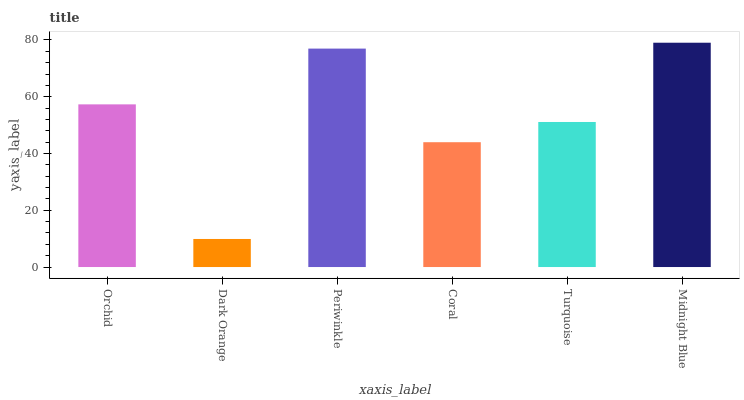Is Dark Orange the minimum?
Answer yes or no. Yes. Is Midnight Blue the maximum?
Answer yes or no. Yes. Is Periwinkle the minimum?
Answer yes or no. No. Is Periwinkle the maximum?
Answer yes or no. No. Is Periwinkle greater than Dark Orange?
Answer yes or no. Yes. Is Dark Orange less than Periwinkle?
Answer yes or no. Yes. Is Dark Orange greater than Periwinkle?
Answer yes or no. No. Is Periwinkle less than Dark Orange?
Answer yes or no. No. Is Orchid the high median?
Answer yes or no. Yes. Is Turquoise the low median?
Answer yes or no. Yes. Is Coral the high median?
Answer yes or no. No. Is Periwinkle the low median?
Answer yes or no. No. 